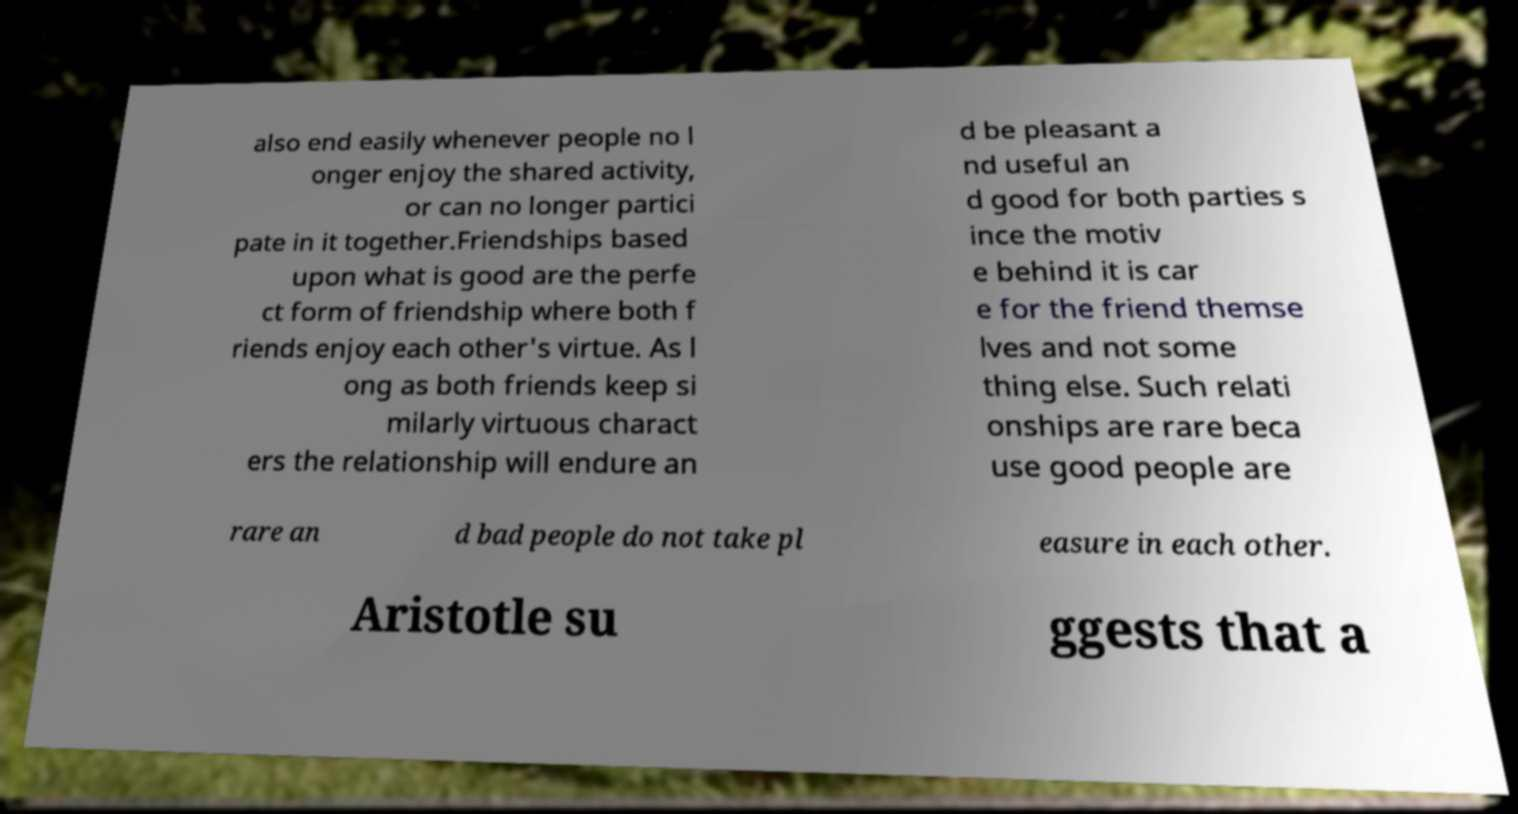What messages or text are displayed in this image? I need them in a readable, typed format. also end easily whenever people no l onger enjoy the shared activity, or can no longer partici pate in it together.Friendships based upon what is good are the perfe ct form of friendship where both f riends enjoy each other's virtue. As l ong as both friends keep si milarly virtuous charact ers the relationship will endure an d be pleasant a nd useful an d good for both parties s ince the motiv e behind it is car e for the friend themse lves and not some thing else. Such relati onships are rare beca use good people are rare an d bad people do not take pl easure in each other. Aristotle su ggests that a 